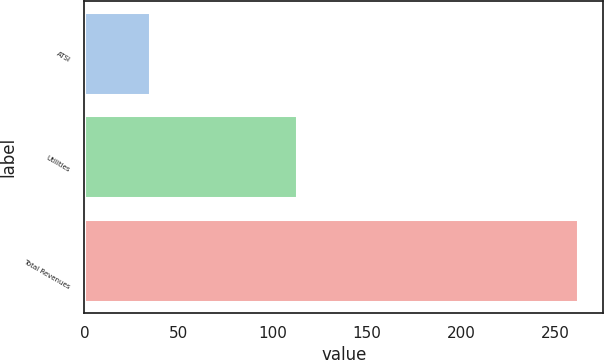Convert chart to OTSL. <chart><loc_0><loc_0><loc_500><loc_500><bar_chart><fcel>ATSI<fcel>Utilities<fcel>Total Revenues<nl><fcel>35<fcel>113<fcel>262<nl></chart> 